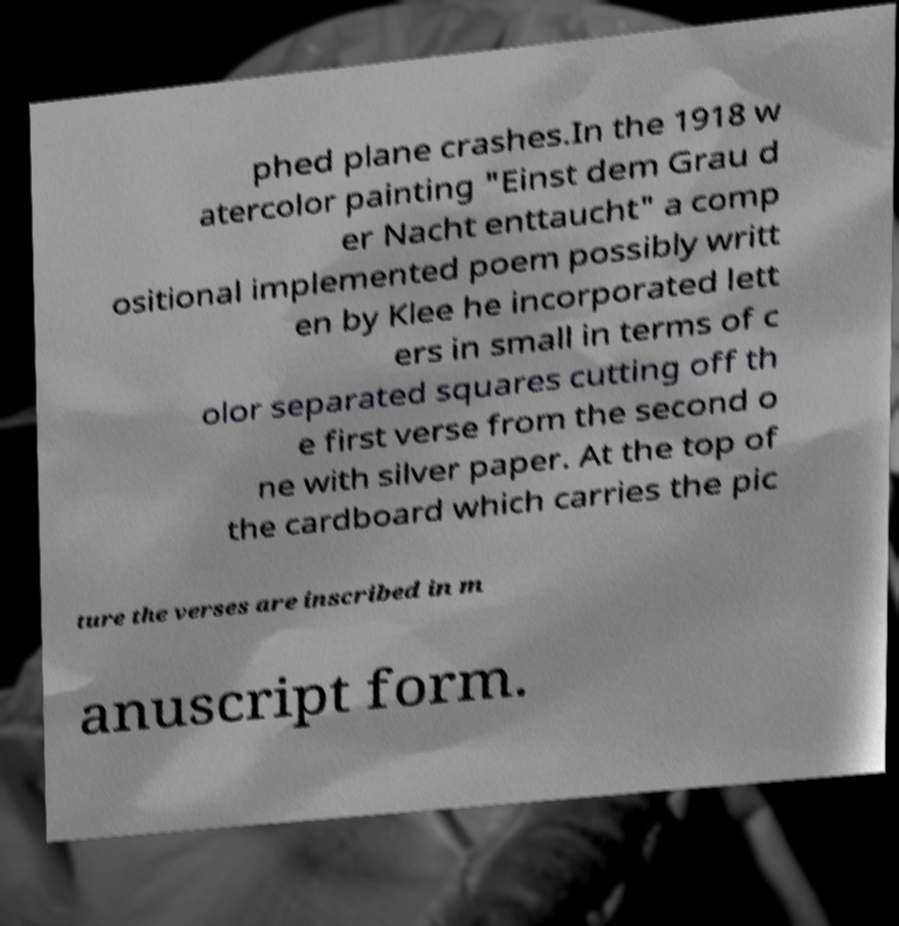Please read and relay the text visible in this image. What does it say? phed plane crashes.In the 1918 w atercolor painting "Einst dem Grau d er Nacht enttaucht" a comp ositional implemented poem possibly writt en by Klee he incorporated lett ers in small in terms of c olor separated squares cutting off th e first verse from the second o ne with silver paper. At the top of the cardboard which carries the pic ture the verses are inscribed in m anuscript form. 